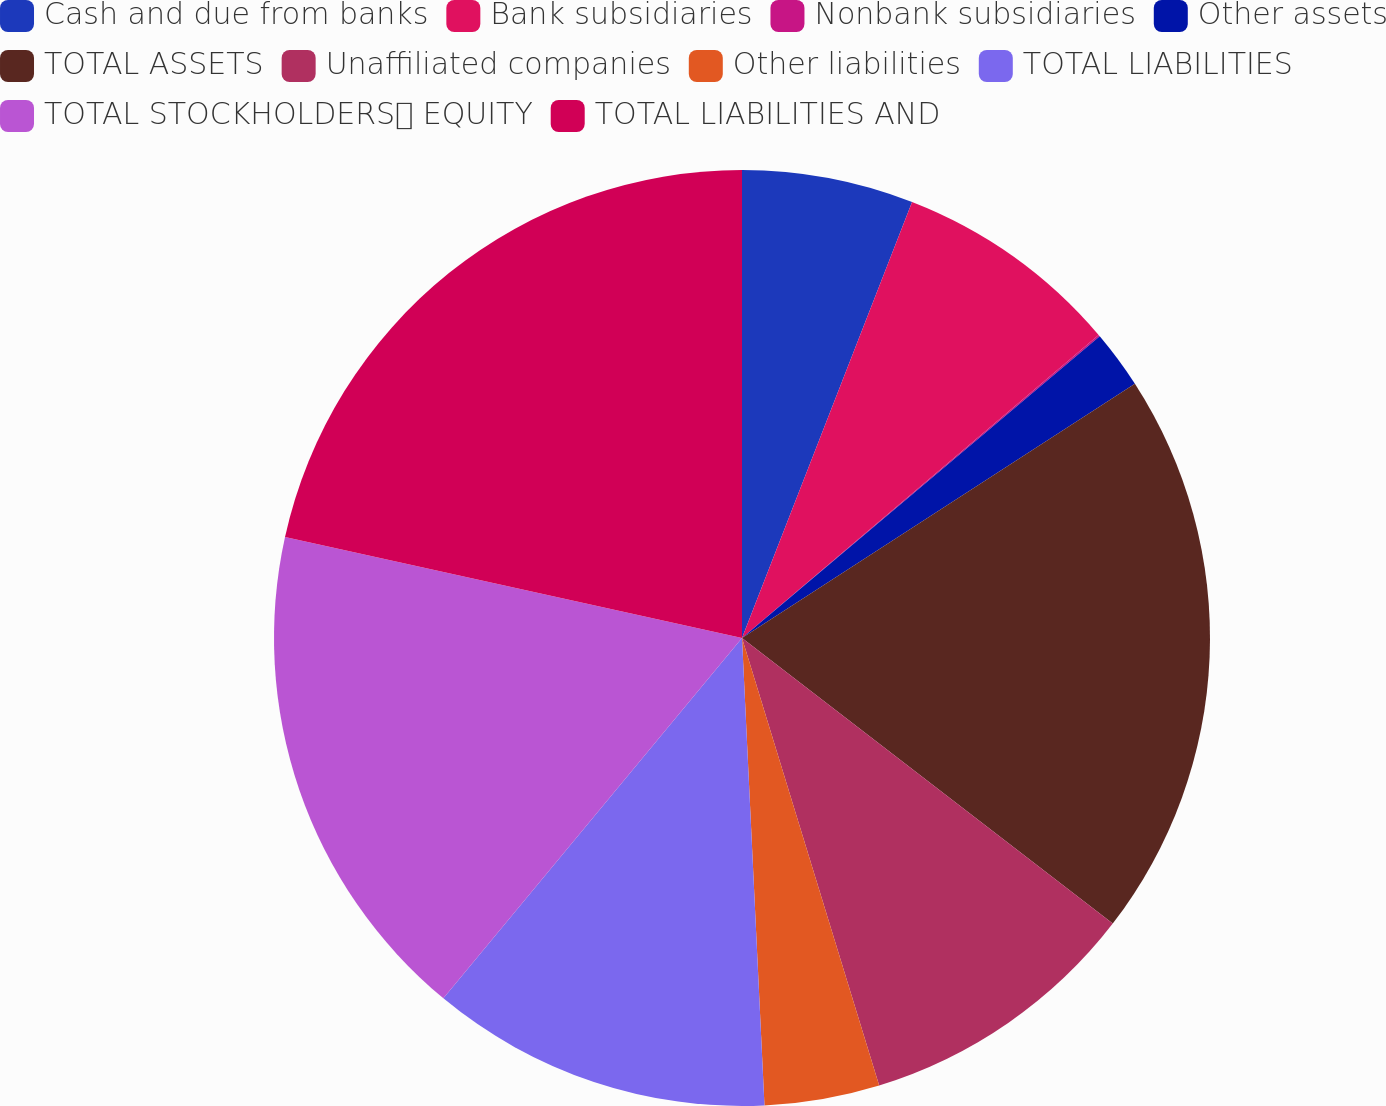Convert chart. <chart><loc_0><loc_0><loc_500><loc_500><pie_chart><fcel>Cash and due from banks<fcel>Bank subsidiaries<fcel>Nonbank subsidiaries<fcel>Other assets<fcel>TOTAL ASSETS<fcel>Unaffiliated companies<fcel>Other liabilities<fcel>TOTAL LIABILITIES<fcel>TOTAL STOCKHOLDERS EQUITY<fcel>TOTAL LIABILITIES AND<nl><fcel>5.92%<fcel>7.87%<fcel>0.06%<fcel>2.01%<fcel>19.59%<fcel>9.82%<fcel>3.97%<fcel>11.78%<fcel>17.45%<fcel>21.54%<nl></chart> 